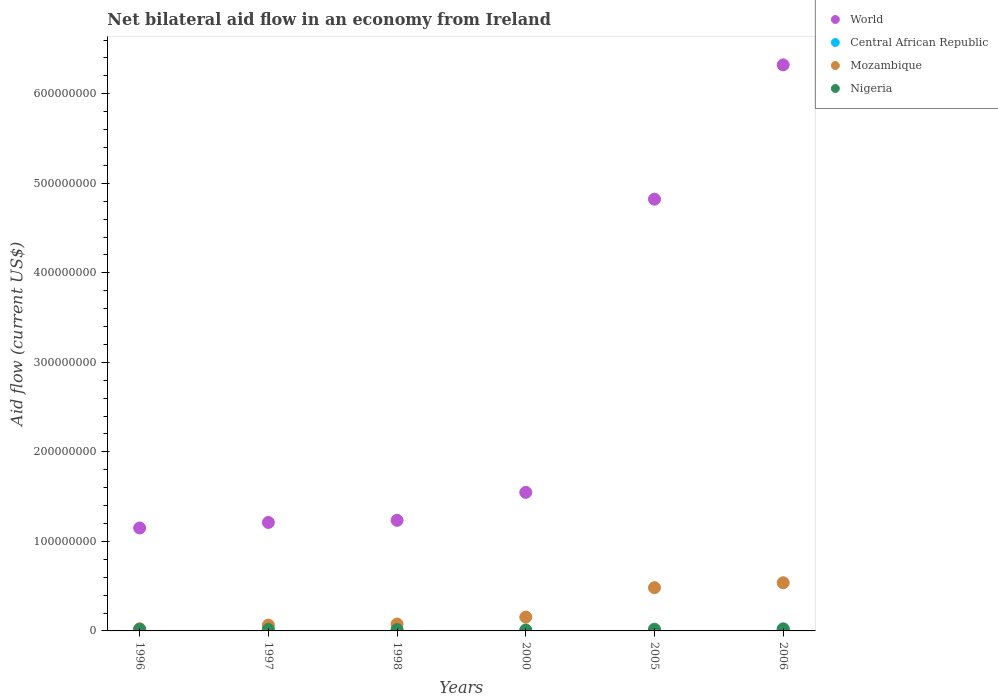How many different coloured dotlines are there?
Your answer should be compact. 4. What is the net bilateral aid flow in World in 2000?
Provide a succinct answer. 1.55e+08. Across all years, what is the maximum net bilateral aid flow in Mozambique?
Ensure brevity in your answer.  5.38e+07. Across all years, what is the minimum net bilateral aid flow in Nigeria?
Your response must be concise. 9.90e+05. In which year was the net bilateral aid flow in Central African Republic maximum?
Your answer should be very brief. 2006. What is the total net bilateral aid flow in Central African Republic in the graph?
Your answer should be compact. 2.30e+06. What is the difference between the net bilateral aid flow in Central African Republic in 1996 and that in 2000?
Ensure brevity in your answer.  0. What is the difference between the net bilateral aid flow in Nigeria in 2006 and the net bilateral aid flow in World in 1996?
Keep it short and to the point. -1.13e+08. What is the average net bilateral aid flow in Mozambique per year?
Make the answer very short. 2.23e+07. In the year 1998, what is the difference between the net bilateral aid flow in Mozambique and net bilateral aid flow in Central African Republic?
Offer a terse response. 7.64e+06. In how many years, is the net bilateral aid flow in Central African Republic greater than 440000000 US$?
Your response must be concise. 0. What is the ratio of the net bilateral aid flow in Central African Republic in 1997 to that in 1998?
Your answer should be very brief. 1.33. Is the net bilateral aid flow in Nigeria in 1996 less than that in 1997?
Keep it short and to the point. No. What is the difference between the highest and the second highest net bilateral aid flow in Mozambique?
Provide a short and direct response. 5.50e+06. What is the difference between the highest and the lowest net bilateral aid flow in World?
Give a very brief answer. 5.17e+08. Is it the case that in every year, the sum of the net bilateral aid flow in Central African Republic and net bilateral aid flow in Nigeria  is greater than the net bilateral aid flow in World?
Give a very brief answer. No. Does the net bilateral aid flow in Mozambique monotonically increase over the years?
Provide a short and direct response. Yes. Is the net bilateral aid flow in World strictly less than the net bilateral aid flow in Nigeria over the years?
Offer a terse response. No. How many dotlines are there?
Your answer should be compact. 4. How many years are there in the graph?
Ensure brevity in your answer.  6. Where does the legend appear in the graph?
Provide a succinct answer. Top right. How many legend labels are there?
Your answer should be compact. 4. How are the legend labels stacked?
Give a very brief answer. Vertical. What is the title of the graph?
Your response must be concise. Net bilateral aid flow in an economy from Ireland. Does "Pacific island small states" appear as one of the legend labels in the graph?
Keep it short and to the point. No. What is the label or title of the X-axis?
Provide a short and direct response. Years. What is the Aid flow (current US$) of World in 1996?
Your response must be concise. 1.15e+08. What is the Aid flow (current US$) of Mozambique in 1996?
Your answer should be compact. 2.37e+06. What is the Aid flow (current US$) in Nigeria in 1996?
Provide a succinct answer. 1.72e+06. What is the Aid flow (current US$) in World in 1997?
Your answer should be compact. 1.21e+08. What is the Aid flow (current US$) of Mozambique in 1997?
Provide a short and direct response. 6.48e+06. What is the Aid flow (current US$) in Nigeria in 1997?
Your answer should be very brief. 1.63e+06. What is the Aid flow (current US$) of World in 1998?
Give a very brief answer. 1.24e+08. What is the Aid flow (current US$) of Central African Republic in 1998?
Give a very brief answer. 3.00e+04. What is the Aid flow (current US$) of Mozambique in 1998?
Your answer should be very brief. 7.67e+06. What is the Aid flow (current US$) in Nigeria in 1998?
Provide a short and direct response. 1.46e+06. What is the Aid flow (current US$) of World in 2000?
Your response must be concise. 1.55e+08. What is the Aid flow (current US$) in Central African Republic in 2000?
Your response must be concise. 2.00e+04. What is the Aid flow (current US$) in Mozambique in 2000?
Give a very brief answer. 1.54e+07. What is the Aid flow (current US$) in Nigeria in 2000?
Your answer should be compact. 9.90e+05. What is the Aid flow (current US$) in World in 2005?
Your response must be concise. 4.82e+08. What is the Aid flow (current US$) in Mozambique in 2005?
Offer a terse response. 4.83e+07. What is the Aid flow (current US$) of Nigeria in 2005?
Your response must be concise. 1.89e+06. What is the Aid flow (current US$) in World in 2006?
Provide a short and direct response. 6.32e+08. What is the Aid flow (current US$) of Central African Republic in 2006?
Offer a very short reply. 1.69e+06. What is the Aid flow (current US$) in Mozambique in 2006?
Provide a succinct answer. 5.38e+07. What is the Aid flow (current US$) in Nigeria in 2006?
Make the answer very short. 2.32e+06. Across all years, what is the maximum Aid flow (current US$) in World?
Provide a succinct answer. 6.32e+08. Across all years, what is the maximum Aid flow (current US$) in Central African Republic?
Ensure brevity in your answer.  1.69e+06. Across all years, what is the maximum Aid flow (current US$) in Mozambique?
Your response must be concise. 5.38e+07. Across all years, what is the maximum Aid flow (current US$) of Nigeria?
Give a very brief answer. 2.32e+06. Across all years, what is the minimum Aid flow (current US$) in World?
Ensure brevity in your answer.  1.15e+08. Across all years, what is the minimum Aid flow (current US$) of Central African Republic?
Your answer should be compact. 2.00e+04. Across all years, what is the minimum Aid flow (current US$) of Mozambique?
Your response must be concise. 2.37e+06. Across all years, what is the minimum Aid flow (current US$) of Nigeria?
Your answer should be very brief. 9.90e+05. What is the total Aid flow (current US$) in World in the graph?
Keep it short and to the point. 1.63e+09. What is the total Aid flow (current US$) in Central African Republic in the graph?
Provide a succinct answer. 2.30e+06. What is the total Aid flow (current US$) in Mozambique in the graph?
Make the answer very short. 1.34e+08. What is the total Aid flow (current US$) in Nigeria in the graph?
Provide a short and direct response. 1.00e+07. What is the difference between the Aid flow (current US$) in World in 1996 and that in 1997?
Offer a terse response. -6.17e+06. What is the difference between the Aid flow (current US$) in Central African Republic in 1996 and that in 1997?
Keep it short and to the point. -2.00e+04. What is the difference between the Aid flow (current US$) of Mozambique in 1996 and that in 1997?
Make the answer very short. -4.11e+06. What is the difference between the Aid flow (current US$) in Nigeria in 1996 and that in 1997?
Keep it short and to the point. 9.00e+04. What is the difference between the Aid flow (current US$) of World in 1996 and that in 1998?
Give a very brief answer. -8.53e+06. What is the difference between the Aid flow (current US$) of Mozambique in 1996 and that in 1998?
Offer a very short reply. -5.30e+06. What is the difference between the Aid flow (current US$) of Nigeria in 1996 and that in 1998?
Make the answer very short. 2.60e+05. What is the difference between the Aid flow (current US$) in World in 1996 and that in 2000?
Provide a succinct answer. -3.98e+07. What is the difference between the Aid flow (current US$) in Central African Republic in 1996 and that in 2000?
Ensure brevity in your answer.  0. What is the difference between the Aid flow (current US$) of Mozambique in 1996 and that in 2000?
Offer a terse response. -1.30e+07. What is the difference between the Aid flow (current US$) of Nigeria in 1996 and that in 2000?
Provide a short and direct response. 7.30e+05. What is the difference between the Aid flow (current US$) in World in 1996 and that in 2005?
Make the answer very short. -3.67e+08. What is the difference between the Aid flow (current US$) of Central African Republic in 1996 and that in 2005?
Offer a terse response. -4.80e+05. What is the difference between the Aid flow (current US$) in Mozambique in 1996 and that in 2005?
Your answer should be compact. -4.59e+07. What is the difference between the Aid flow (current US$) in Nigeria in 1996 and that in 2005?
Your response must be concise. -1.70e+05. What is the difference between the Aid flow (current US$) of World in 1996 and that in 2006?
Make the answer very short. -5.17e+08. What is the difference between the Aid flow (current US$) in Central African Republic in 1996 and that in 2006?
Your answer should be compact. -1.67e+06. What is the difference between the Aid flow (current US$) in Mozambique in 1996 and that in 2006?
Give a very brief answer. -5.14e+07. What is the difference between the Aid flow (current US$) of Nigeria in 1996 and that in 2006?
Provide a short and direct response. -6.00e+05. What is the difference between the Aid flow (current US$) in World in 1997 and that in 1998?
Your answer should be very brief. -2.36e+06. What is the difference between the Aid flow (current US$) in Mozambique in 1997 and that in 1998?
Your answer should be compact. -1.19e+06. What is the difference between the Aid flow (current US$) in Nigeria in 1997 and that in 1998?
Make the answer very short. 1.70e+05. What is the difference between the Aid flow (current US$) of World in 1997 and that in 2000?
Keep it short and to the point. -3.36e+07. What is the difference between the Aid flow (current US$) of Central African Republic in 1997 and that in 2000?
Offer a terse response. 2.00e+04. What is the difference between the Aid flow (current US$) in Mozambique in 1997 and that in 2000?
Your answer should be very brief. -8.91e+06. What is the difference between the Aid flow (current US$) in Nigeria in 1997 and that in 2000?
Your answer should be very brief. 6.40e+05. What is the difference between the Aid flow (current US$) in World in 1997 and that in 2005?
Keep it short and to the point. -3.61e+08. What is the difference between the Aid flow (current US$) in Central African Republic in 1997 and that in 2005?
Provide a succinct answer. -4.60e+05. What is the difference between the Aid flow (current US$) in Mozambique in 1997 and that in 2005?
Your answer should be compact. -4.18e+07. What is the difference between the Aid flow (current US$) in World in 1997 and that in 2006?
Your answer should be very brief. -5.11e+08. What is the difference between the Aid flow (current US$) of Central African Republic in 1997 and that in 2006?
Your response must be concise. -1.65e+06. What is the difference between the Aid flow (current US$) in Mozambique in 1997 and that in 2006?
Keep it short and to the point. -4.73e+07. What is the difference between the Aid flow (current US$) in Nigeria in 1997 and that in 2006?
Your answer should be very brief. -6.90e+05. What is the difference between the Aid flow (current US$) in World in 1998 and that in 2000?
Your answer should be very brief. -3.12e+07. What is the difference between the Aid flow (current US$) in Mozambique in 1998 and that in 2000?
Give a very brief answer. -7.72e+06. What is the difference between the Aid flow (current US$) of Nigeria in 1998 and that in 2000?
Give a very brief answer. 4.70e+05. What is the difference between the Aid flow (current US$) of World in 1998 and that in 2005?
Your answer should be very brief. -3.59e+08. What is the difference between the Aid flow (current US$) of Central African Republic in 1998 and that in 2005?
Your answer should be very brief. -4.70e+05. What is the difference between the Aid flow (current US$) in Mozambique in 1998 and that in 2005?
Offer a terse response. -4.06e+07. What is the difference between the Aid flow (current US$) of Nigeria in 1998 and that in 2005?
Offer a very short reply. -4.30e+05. What is the difference between the Aid flow (current US$) of World in 1998 and that in 2006?
Offer a terse response. -5.09e+08. What is the difference between the Aid flow (current US$) in Central African Republic in 1998 and that in 2006?
Provide a succinct answer. -1.66e+06. What is the difference between the Aid flow (current US$) in Mozambique in 1998 and that in 2006?
Make the answer very short. -4.61e+07. What is the difference between the Aid flow (current US$) in Nigeria in 1998 and that in 2006?
Provide a short and direct response. -8.60e+05. What is the difference between the Aid flow (current US$) in World in 2000 and that in 2005?
Keep it short and to the point. -3.28e+08. What is the difference between the Aid flow (current US$) in Central African Republic in 2000 and that in 2005?
Give a very brief answer. -4.80e+05. What is the difference between the Aid flow (current US$) in Mozambique in 2000 and that in 2005?
Make the answer very short. -3.29e+07. What is the difference between the Aid flow (current US$) of Nigeria in 2000 and that in 2005?
Make the answer very short. -9.00e+05. What is the difference between the Aid flow (current US$) of World in 2000 and that in 2006?
Keep it short and to the point. -4.78e+08. What is the difference between the Aid flow (current US$) of Central African Republic in 2000 and that in 2006?
Your answer should be compact. -1.67e+06. What is the difference between the Aid flow (current US$) in Mozambique in 2000 and that in 2006?
Offer a terse response. -3.84e+07. What is the difference between the Aid flow (current US$) of Nigeria in 2000 and that in 2006?
Provide a short and direct response. -1.33e+06. What is the difference between the Aid flow (current US$) in World in 2005 and that in 2006?
Provide a short and direct response. -1.50e+08. What is the difference between the Aid flow (current US$) of Central African Republic in 2005 and that in 2006?
Your response must be concise. -1.19e+06. What is the difference between the Aid flow (current US$) of Mozambique in 2005 and that in 2006?
Give a very brief answer. -5.50e+06. What is the difference between the Aid flow (current US$) of Nigeria in 2005 and that in 2006?
Offer a very short reply. -4.30e+05. What is the difference between the Aid flow (current US$) of World in 1996 and the Aid flow (current US$) of Central African Republic in 1997?
Make the answer very short. 1.15e+08. What is the difference between the Aid flow (current US$) of World in 1996 and the Aid flow (current US$) of Mozambique in 1997?
Make the answer very short. 1.09e+08. What is the difference between the Aid flow (current US$) in World in 1996 and the Aid flow (current US$) in Nigeria in 1997?
Give a very brief answer. 1.13e+08. What is the difference between the Aid flow (current US$) in Central African Republic in 1996 and the Aid flow (current US$) in Mozambique in 1997?
Offer a very short reply. -6.46e+06. What is the difference between the Aid flow (current US$) of Central African Republic in 1996 and the Aid flow (current US$) of Nigeria in 1997?
Provide a short and direct response. -1.61e+06. What is the difference between the Aid flow (current US$) of Mozambique in 1996 and the Aid flow (current US$) of Nigeria in 1997?
Keep it short and to the point. 7.40e+05. What is the difference between the Aid flow (current US$) in World in 1996 and the Aid flow (current US$) in Central African Republic in 1998?
Keep it short and to the point. 1.15e+08. What is the difference between the Aid flow (current US$) in World in 1996 and the Aid flow (current US$) in Mozambique in 1998?
Keep it short and to the point. 1.07e+08. What is the difference between the Aid flow (current US$) in World in 1996 and the Aid flow (current US$) in Nigeria in 1998?
Keep it short and to the point. 1.14e+08. What is the difference between the Aid flow (current US$) in Central African Republic in 1996 and the Aid flow (current US$) in Mozambique in 1998?
Give a very brief answer. -7.65e+06. What is the difference between the Aid flow (current US$) of Central African Republic in 1996 and the Aid flow (current US$) of Nigeria in 1998?
Offer a very short reply. -1.44e+06. What is the difference between the Aid flow (current US$) of Mozambique in 1996 and the Aid flow (current US$) of Nigeria in 1998?
Your response must be concise. 9.10e+05. What is the difference between the Aid flow (current US$) of World in 1996 and the Aid flow (current US$) of Central African Republic in 2000?
Your answer should be compact. 1.15e+08. What is the difference between the Aid flow (current US$) of World in 1996 and the Aid flow (current US$) of Mozambique in 2000?
Offer a terse response. 9.96e+07. What is the difference between the Aid flow (current US$) in World in 1996 and the Aid flow (current US$) in Nigeria in 2000?
Provide a short and direct response. 1.14e+08. What is the difference between the Aid flow (current US$) in Central African Republic in 1996 and the Aid flow (current US$) in Mozambique in 2000?
Your answer should be compact. -1.54e+07. What is the difference between the Aid flow (current US$) in Central African Republic in 1996 and the Aid flow (current US$) in Nigeria in 2000?
Provide a succinct answer. -9.70e+05. What is the difference between the Aid flow (current US$) in Mozambique in 1996 and the Aid flow (current US$) in Nigeria in 2000?
Your answer should be very brief. 1.38e+06. What is the difference between the Aid flow (current US$) of World in 1996 and the Aid flow (current US$) of Central African Republic in 2005?
Your response must be concise. 1.14e+08. What is the difference between the Aid flow (current US$) in World in 1996 and the Aid flow (current US$) in Mozambique in 2005?
Give a very brief answer. 6.67e+07. What is the difference between the Aid flow (current US$) in World in 1996 and the Aid flow (current US$) in Nigeria in 2005?
Offer a very short reply. 1.13e+08. What is the difference between the Aid flow (current US$) of Central African Republic in 1996 and the Aid flow (current US$) of Mozambique in 2005?
Your answer should be compact. -4.83e+07. What is the difference between the Aid flow (current US$) of Central African Republic in 1996 and the Aid flow (current US$) of Nigeria in 2005?
Ensure brevity in your answer.  -1.87e+06. What is the difference between the Aid flow (current US$) of World in 1996 and the Aid flow (current US$) of Central African Republic in 2006?
Ensure brevity in your answer.  1.13e+08. What is the difference between the Aid flow (current US$) of World in 1996 and the Aid flow (current US$) of Mozambique in 2006?
Provide a succinct answer. 6.12e+07. What is the difference between the Aid flow (current US$) in World in 1996 and the Aid flow (current US$) in Nigeria in 2006?
Your answer should be very brief. 1.13e+08. What is the difference between the Aid flow (current US$) in Central African Republic in 1996 and the Aid flow (current US$) in Mozambique in 2006?
Give a very brief answer. -5.38e+07. What is the difference between the Aid flow (current US$) of Central African Republic in 1996 and the Aid flow (current US$) of Nigeria in 2006?
Your answer should be very brief. -2.30e+06. What is the difference between the Aid flow (current US$) in Mozambique in 1996 and the Aid flow (current US$) in Nigeria in 2006?
Offer a terse response. 5.00e+04. What is the difference between the Aid flow (current US$) of World in 1997 and the Aid flow (current US$) of Central African Republic in 1998?
Keep it short and to the point. 1.21e+08. What is the difference between the Aid flow (current US$) in World in 1997 and the Aid flow (current US$) in Mozambique in 1998?
Provide a succinct answer. 1.13e+08. What is the difference between the Aid flow (current US$) of World in 1997 and the Aid flow (current US$) of Nigeria in 1998?
Provide a short and direct response. 1.20e+08. What is the difference between the Aid flow (current US$) in Central African Republic in 1997 and the Aid flow (current US$) in Mozambique in 1998?
Make the answer very short. -7.63e+06. What is the difference between the Aid flow (current US$) in Central African Republic in 1997 and the Aid flow (current US$) in Nigeria in 1998?
Provide a short and direct response. -1.42e+06. What is the difference between the Aid flow (current US$) in Mozambique in 1997 and the Aid flow (current US$) in Nigeria in 1998?
Offer a very short reply. 5.02e+06. What is the difference between the Aid flow (current US$) of World in 1997 and the Aid flow (current US$) of Central African Republic in 2000?
Provide a short and direct response. 1.21e+08. What is the difference between the Aid flow (current US$) in World in 1997 and the Aid flow (current US$) in Mozambique in 2000?
Provide a short and direct response. 1.06e+08. What is the difference between the Aid flow (current US$) in World in 1997 and the Aid flow (current US$) in Nigeria in 2000?
Give a very brief answer. 1.20e+08. What is the difference between the Aid flow (current US$) in Central African Republic in 1997 and the Aid flow (current US$) in Mozambique in 2000?
Provide a short and direct response. -1.54e+07. What is the difference between the Aid flow (current US$) in Central African Republic in 1997 and the Aid flow (current US$) in Nigeria in 2000?
Provide a succinct answer. -9.50e+05. What is the difference between the Aid flow (current US$) in Mozambique in 1997 and the Aid flow (current US$) in Nigeria in 2000?
Ensure brevity in your answer.  5.49e+06. What is the difference between the Aid flow (current US$) in World in 1997 and the Aid flow (current US$) in Central African Republic in 2005?
Ensure brevity in your answer.  1.21e+08. What is the difference between the Aid flow (current US$) in World in 1997 and the Aid flow (current US$) in Mozambique in 2005?
Your answer should be very brief. 7.28e+07. What is the difference between the Aid flow (current US$) of World in 1997 and the Aid flow (current US$) of Nigeria in 2005?
Your answer should be very brief. 1.19e+08. What is the difference between the Aid flow (current US$) in Central African Republic in 1997 and the Aid flow (current US$) in Mozambique in 2005?
Your response must be concise. -4.83e+07. What is the difference between the Aid flow (current US$) in Central African Republic in 1997 and the Aid flow (current US$) in Nigeria in 2005?
Provide a succinct answer. -1.85e+06. What is the difference between the Aid flow (current US$) in Mozambique in 1997 and the Aid flow (current US$) in Nigeria in 2005?
Your answer should be compact. 4.59e+06. What is the difference between the Aid flow (current US$) of World in 1997 and the Aid flow (current US$) of Central African Republic in 2006?
Keep it short and to the point. 1.19e+08. What is the difference between the Aid flow (current US$) in World in 1997 and the Aid flow (current US$) in Mozambique in 2006?
Give a very brief answer. 6.74e+07. What is the difference between the Aid flow (current US$) of World in 1997 and the Aid flow (current US$) of Nigeria in 2006?
Your answer should be very brief. 1.19e+08. What is the difference between the Aid flow (current US$) in Central African Republic in 1997 and the Aid flow (current US$) in Mozambique in 2006?
Your response must be concise. -5.38e+07. What is the difference between the Aid flow (current US$) in Central African Republic in 1997 and the Aid flow (current US$) in Nigeria in 2006?
Offer a terse response. -2.28e+06. What is the difference between the Aid flow (current US$) in Mozambique in 1997 and the Aid flow (current US$) in Nigeria in 2006?
Provide a short and direct response. 4.16e+06. What is the difference between the Aid flow (current US$) in World in 1998 and the Aid flow (current US$) in Central African Republic in 2000?
Your answer should be very brief. 1.24e+08. What is the difference between the Aid flow (current US$) in World in 1998 and the Aid flow (current US$) in Mozambique in 2000?
Keep it short and to the point. 1.08e+08. What is the difference between the Aid flow (current US$) in World in 1998 and the Aid flow (current US$) in Nigeria in 2000?
Give a very brief answer. 1.23e+08. What is the difference between the Aid flow (current US$) in Central African Republic in 1998 and the Aid flow (current US$) in Mozambique in 2000?
Keep it short and to the point. -1.54e+07. What is the difference between the Aid flow (current US$) in Central African Republic in 1998 and the Aid flow (current US$) in Nigeria in 2000?
Your answer should be very brief. -9.60e+05. What is the difference between the Aid flow (current US$) in Mozambique in 1998 and the Aid flow (current US$) in Nigeria in 2000?
Make the answer very short. 6.68e+06. What is the difference between the Aid flow (current US$) of World in 1998 and the Aid flow (current US$) of Central African Republic in 2005?
Your answer should be compact. 1.23e+08. What is the difference between the Aid flow (current US$) in World in 1998 and the Aid flow (current US$) in Mozambique in 2005?
Keep it short and to the point. 7.52e+07. What is the difference between the Aid flow (current US$) in World in 1998 and the Aid flow (current US$) in Nigeria in 2005?
Your answer should be compact. 1.22e+08. What is the difference between the Aid flow (current US$) in Central African Republic in 1998 and the Aid flow (current US$) in Mozambique in 2005?
Provide a succinct answer. -4.83e+07. What is the difference between the Aid flow (current US$) in Central African Republic in 1998 and the Aid flow (current US$) in Nigeria in 2005?
Your answer should be very brief. -1.86e+06. What is the difference between the Aid flow (current US$) of Mozambique in 1998 and the Aid flow (current US$) of Nigeria in 2005?
Your answer should be compact. 5.78e+06. What is the difference between the Aid flow (current US$) in World in 1998 and the Aid flow (current US$) in Central African Republic in 2006?
Offer a terse response. 1.22e+08. What is the difference between the Aid flow (current US$) in World in 1998 and the Aid flow (current US$) in Mozambique in 2006?
Offer a terse response. 6.97e+07. What is the difference between the Aid flow (current US$) of World in 1998 and the Aid flow (current US$) of Nigeria in 2006?
Your answer should be compact. 1.21e+08. What is the difference between the Aid flow (current US$) in Central African Republic in 1998 and the Aid flow (current US$) in Mozambique in 2006?
Your answer should be very brief. -5.38e+07. What is the difference between the Aid flow (current US$) of Central African Republic in 1998 and the Aid flow (current US$) of Nigeria in 2006?
Offer a very short reply. -2.29e+06. What is the difference between the Aid flow (current US$) of Mozambique in 1998 and the Aid flow (current US$) of Nigeria in 2006?
Offer a very short reply. 5.35e+06. What is the difference between the Aid flow (current US$) in World in 2000 and the Aid flow (current US$) in Central African Republic in 2005?
Provide a succinct answer. 1.54e+08. What is the difference between the Aid flow (current US$) in World in 2000 and the Aid flow (current US$) in Mozambique in 2005?
Offer a very short reply. 1.06e+08. What is the difference between the Aid flow (current US$) of World in 2000 and the Aid flow (current US$) of Nigeria in 2005?
Your answer should be very brief. 1.53e+08. What is the difference between the Aid flow (current US$) of Central African Republic in 2000 and the Aid flow (current US$) of Mozambique in 2005?
Give a very brief answer. -4.83e+07. What is the difference between the Aid flow (current US$) of Central African Republic in 2000 and the Aid flow (current US$) of Nigeria in 2005?
Your answer should be compact. -1.87e+06. What is the difference between the Aid flow (current US$) of Mozambique in 2000 and the Aid flow (current US$) of Nigeria in 2005?
Your answer should be compact. 1.35e+07. What is the difference between the Aid flow (current US$) of World in 2000 and the Aid flow (current US$) of Central African Republic in 2006?
Make the answer very short. 1.53e+08. What is the difference between the Aid flow (current US$) of World in 2000 and the Aid flow (current US$) of Mozambique in 2006?
Ensure brevity in your answer.  1.01e+08. What is the difference between the Aid flow (current US$) of World in 2000 and the Aid flow (current US$) of Nigeria in 2006?
Your answer should be very brief. 1.52e+08. What is the difference between the Aid flow (current US$) of Central African Republic in 2000 and the Aid flow (current US$) of Mozambique in 2006?
Make the answer very short. -5.38e+07. What is the difference between the Aid flow (current US$) of Central African Republic in 2000 and the Aid flow (current US$) of Nigeria in 2006?
Offer a very short reply. -2.30e+06. What is the difference between the Aid flow (current US$) in Mozambique in 2000 and the Aid flow (current US$) in Nigeria in 2006?
Your answer should be very brief. 1.31e+07. What is the difference between the Aid flow (current US$) in World in 2005 and the Aid flow (current US$) in Central African Republic in 2006?
Ensure brevity in your answer.  4.81e+08. What is the difference between the Aid flow (current US$) in World in 2005 and the Aid flow (current US$) in Mozambique in 2006?
Your answer should be very brief. 4.28e+08. What is the difference between the Aid flow (current US$) of World in 2005 and the Aid flow (current US$) of Nigeria in 2006?
Your answer should be compact. 4.80e+08. What is the difference between the Aid flow (current US$) of Central African Republic in 2005 and the Aid flow (current US$) of Mozambique in 2006?
Offer a terse response. -5.33e+07. What is the difference between the Aid flow (current US$) in Central African Republic in 2005 and the Aid flow (current US$) in Nigeria in 2006?
Offer a terse response. -1.82e+06. What is the difference between the Aid flow (current US$) in Mozambique in 2005 and the Aid flow (current US$) in Nigeria in 2006?
Your answer should be very brief. 4.60e+07. What is the average Aid flow (current US$) of World per year?
Offer a terse response. 2.71e+08. What is the average Aid flow (current US$) of Central African Republic per year?
Offer a very short reply. 3.83e+05. What is the average Aid flow (current US$) of Mozambique per year?
Give a very brief answer. 2.23e+07. What is the average Aid flow (current US$) of Nigeria per year?
Offer a very short reply. 1.67e+06. In the year 1996, what is the difference between the Aid flow (current US$) of World and Aid flow (current US$) of Central African Republic?
Offer a terse response. 1.15e+08. In the year 1996, what is the difference between the Aid flow (current US$) in World and Aid flow (current US$) in Mozambique?
Offer a terse response. 1.13e+08. In the year 1996, what is the difference between the Aid flow (current US$) of World and Aid flow (current US$) of Nigeria?
Keep it short and to the point. 1.13e+08. In the year 1996, what is the difference between the Aid flow (current US$) of Central African Republic and Aid flow (current US$) of Mozambique?
Your response must be concise. -2.35e+06. In the year 1996, what is the difference between the Aid flow (current US$) in Central African Republic and Aid flow (current US$) in Nigeria?
Offer a very short reply. -1.70e+06. In the year 1996, what is the difference between the Aid flow (current US$) in Mozambique and Aid flow (current US$) in Nigeria?
Provide a short and direct response. 6.50e+05. In the year 1997, what is the difference between the Aid flow (current US$) of World and Aid flow (current US$) of Central African Republic?
Offer a very short reply. 1.21e+08. In the year 1997, what is the difference between the Aid flow (current US$) of World and Aid flow (current US$) of Mozambique?
Provide a succinct answer. 1.15e+08. In the year 1997, what is the difference between the Aid flow (current US$) in World and Aid flow (current US$) in Nigeria?
Your answer should be very brief. 1.20e+08. In the year 1997, what is the difference between the Aid flow (current US$) of Central African Republic and Aid flow (current US$) of Mozambique?
Ensure brevity in your answer.  -6.44e+06. In the year 1997, what is the difference between the Aid flow (current US$) in Central African Republic and Aid flow (current US$) in Nigeria?
Offer a very short reply. -1.59e+06. In the year 1997, what is the difference between the Aid flow (current US$) in Mozambique and Aid flow (current US$) in Nigeria?
Your answer should be compact. 4.85e+06. In the year 1998, what is the difference between the Aid flow (current US$) in World and Aid flow (current US$) in Central African Republic?
Make the answer very short. 1.23e+08. In the year 1998, what is the difference between the Aid flow (current US$) of World and Aid flow (current US$) of Mozambique?
Give a very brief answer. 1.16e+08. In the year 1998, what is the difference between the Aid flow (current US$) of World and Aid flow (current US$) of Nigeria?
Your answer should be very brief. 1.22e+08. In the year 1998, what is the difference between the Aid flow (current US$) in Central African Republic and Aid flow (current US$) in Mozambique?
Your answer should be compact. -7.64e+06. In the year 1998, what is the difference between the Aid flow (current US$) in Central African Republic and Aid flow (current US$) in Nigeria?
Give a very brief answer. -1.43e+06. In the year 1998, what is the difference between the Aid flow (current US$) of Mozambique and Aid flow (current US$) of Nigeria?
Your response must be concise. 6.21e+06. In the year 2000, what is the difference between the Aid flow (current US$) of World and Aid flow (current US$) of Central African Republic?
Your answer should be very brief. 1.55e+08. In the year 2000, what is the difference between the Aid flow (current US$) in World and Aid flow (current US$) in Mozambique?
Give a very brief answer. 1.39e+08. In the year 2000, what is the difference between the Aid flow (current US$) in World and Aid flow (current US$) in Nigeria?
Keep it short and to the point. 1.54e+08. In the year 2000, what is the difference between the Aid flow (current US$) in Central African Republic and Aid flow (current US$) in Mozambique?
Provide a succinct answer. -1.54e+07. In the year 2000, what is the difference between the Aid flow (current US$) of Central African Republic and Aid flow (current US$) of Nigeria?
Provide a succinct answer. -9.70e+05. In the year 2000, what is the difference between the Aid flow (current US$) in Mozambique and Aid flow (current US$) in Nigeria?
Make the answer very short. 1.44e+07. In the year 2005, what is the difference between the Aid flow (current US$) of World and Aid flow (current US$) of Central African Republic?
Offer a very short reply. 4.82e+08. In the year 2005, what is the difference between the Aid flow (current US$) of World and Aid flow (current US$) of Mozambique?
Keep it short and to the point. 4.34e+08. In the year 2005, what is the difference between the Aid flow (current US$) of World and Aid flow (current US$) of Nigeria?
Provide a short and direct response. 4.80e+08. In the year 2005, what is the difference between the Aid flow (current US$) in Central African Republic and Aid flow (current US$) in Mozambique?
Offer a very short reply. -4.78e+07. In the year 2005, what is the difference between the Aid flow (current US$) of Central African Republic and Aid flow (current US$) of Nigeria?
Your answer should be compact. -1.39e+06. In the year 2005, what is the difference between the Aid flow (current US$) in Mozambique and Aid flow (current US$) in Nigeria?
Offer a terse response. 4.64e+07. In the year 2006, what is the difference between the Aid flow (current US$) in World and Aid flow (current US$) in Central African Republic?
Offer a very short reply. 6.31e+08. In the year 2006, what is the difference between the Aid flow (current US$) of World and Aid flow (current US$) of Mozambique?
Your answer should be very brief. 5.78e+08. In the year 2006, what is the difference between the Aid flow (current US$) of World and Aid flow (current US$) of Nigeria?
Offer a terse response. 6.30e+08. In the year 2006, what is the difference between the Aid flow (current US$) of Central African Republic and Aid flow (current US$) of Mozambique?
Provide a succinct answer. -5.21e+07. In the year 2006, what is the difference between the Aid flow (current US$) of Central African Republic and Aid flow (current US$) of Nigeria?
Provide a short and direct response. -6.30e+05. In the year 2006, what is the difference between the Aid flow (current US$) in Mozambique and Aid flow (current US$) in Nigeria?
Your answer should be very brief. 5.15e+07. What is the ratio of the Aid flow (current US$) of World in 1996 to that in 1997?
Ensure brevity in your answer.  0.95. What is the ratio of the Aid flow (current US$) of Mozambique in 1996 to that in 1997?
Provide a succinct answer. 0.37. What is the ratio of the Aid flow (current US$) of Nigeria in 1996 to that in 1997?
Give a very brief answer. 1.06. What is the ratio of the Aid flow (current US$) of World in 1996 to that in 1998?
Give a very brief answer. 0.93. What is the ratio of the Aid flow (current US$) of Central African Republic in 1996 to that in 1998?
Make the answer very short. 0.67. What is the ratio of the Aid flow (current US$) in Mozambique in 1996 to that in 1998?
Offer a terse response. 0.31. What is the ratio of the Aid flow (current US$) of Nigeria in 1996 to that in 1998?
Ensure brevity in your answer.  1.18. What is the ratio of the Aid flow (current US$) of World in 1996 to that in 2000?
Give a very brief answer. 0.74. What is the ratio of the Aid flow (current US$) in Mozambique in 1996 to that in 2000?
Offer a very short reply. 0.15. What is the ratio of the Aid flow (current US$) in Nigeria in 1996 to that in 2000?
Ensure brevity in your answer.  1.74. What is the ratio of the Aid flow (current US$) of World in 1996 to that in 2005?
Provide a short and direct response. 0.24. What is the ratio of the Aid flow (current US$) in Central African Republic in 1996 to that in 2005?
Ensure brevity in your answer.  0.04. What is the ratio of the Aid flow (current US$) in Mozambique in 1996 to that in 2005?
Give a very brief answer. 0.05. What is the ratio of the Aid flow (current US$) in Nigeria in 1996 to that in 2005?
Provide a short and direct response. 0.91. What is the ratio of the Aid flow (current US$) in World in 1996 to that in 2006?
Ensure brevity in your answer.  0.18. What is the ratio of the Aid flow (current US$) of Central African Republic in 1996 to that in 2006?
Offer a terse response. 0.01. What is the ratio of the Aid flow (current US$) in Mozambique in 1996 to that in 2006?
Give a very brief answer. 0.04. What is the ratio of the Aid flow (current US$) in Nigeria in 1996 to that in 2006?
Give a very brief answer. 0.74. What is the ratio of the Aid flow (current US$) in World in 1997 to that in 1998?
Provide a short and direct response. 0.98. What is the ratio of the Aid flow (current US$) of Central African Republic in 1997 to that in 1998?
Your answer should be compact. 1.33. What is the ratio of the Aid flow (current US$) in Mozambique in 1997 to that in 1998?
Make the answer very short. 0.84. What is the ratio of the Aid flow (current US$) in Nigeria in 1997 to that in 1998?
Your answer should be compact. 1.12. What is the ratio of the Aid flow (current US$) of World in 1997 to that in 2000?
Offer a very short reply. 0.78. What is the ratio of the Aid flow (current US$) in Central African Republic in 1997 to that in 2000?
Provide a succinct answer. 2. What is the ratio of the Aid flow (current US$) in Mozambique in 1997 to that in 2000?
Keep it short and to the point. 0.42. What is the ratio of the Aid flow (current US$) of Nigeria in 1997 to that in 2000?
Provide a succinct answer. 1.65. What is the ratio of the Aid flow (current US$) of World in 1997 to that in 2005?
Offer a terse response. 0.25. What is the ratio of the Aid flow (current US$) of Central African Republic in 1997 to that in 2005?
Your answer should be very brief. 0.08. What is the ratio of the Aid flow (current US$) of Mozambique in 1997 to that in 2005?
Your answer should be compact. 0.13. What is the ratio of the Aid flow (current US$) of Nigeria in 1997 to that in 2005?
Your response must be concise. 0.86. What is the ratio of the Aid flow (current US$) of World in 1997 to that in 2006?
Keep it short and to the point. 0.19. What is the ratio of the Aid flow (current US$) of Central African Republic in 1997 to that in 2006?
Offer a very short reply. 0.02. What is the ratio of the Aid flow (current US$) in Mozambique in 1997 to that in 2006?
Offer a terse response. 0.12. What is the ratio of the Aid flow (current US$) of Nigeria in 1997 to that in 2006?
Give a very brief answer. 0.7. What is the ratio of the Aid flow (current US$) of World in 1998 to that in 2000?
Your response must be concise. 0.8. What is the ratio of the Aid flow (current US$) of Central African Republic in 1998 to that in 2000?
Ensure brevity in your answer.  1.5. What is the ratio of the Aid flow (current US$) of Mozambique in 1998 to that in 2000?
Give a very brief answer. 0.5. What is the ratio of the Aid flow (current US$) of Nigeria in 1998 to that in 2000?
Your answer should be compact. 1.47. What is the ratio of the Aid flow (current US$) in World in 1998 to that in 2005?
Your answer should be very brief. 0.26. What is the ratio of the Aid flow (current US$) of Central African Republic in 1998 to that in 2005?
Your response must be concise. 0.06. What is the ratio of the Aid flow (current US$) in Mozambique in 1998 to that in 2005?
Give a very brief answer. 0.16. What is the ratio of the Aid flow (current US$) in Nigeria in 1998 to that in 2005?
Give a very brief answer. 0.77. What is the ratio of the Aid flow (current US$) in World in 1998 to that in 2006?
Offer a very short reply. 0.2. What is the ratio of the Aid flow (current US$) in Central African Republic in 1998 to that in 2006?
Provide a short and direct response. 0.02. What is the ratio of the Aid flow (current US$) in Mozambique in 1998 to that in 2006?
Your answer should be very brief. 0.14. What is the ratio of the Aid flow (current US$) of Nigeria in 1998 to that in 2006?
Keep it short and to the point. 0.63. What is the ratio of the Aid flow (current US$) in World in 2000 to that in 2005?
Ensure brevity in your answer.  0.32. What is the ratio of the Aid flow (current US$) of Mozambique in 2000 to that in 2005?
Your response must be concise. 0.32. What is the ratio of the Aid flow (current US$) of Nigeria in 2000 to that in 2005?
Offer a terse response. 0.52. What is the ratio of the Aid flow (current US$) of World in 2000 to that in 2006?
Offer a terse response. 0.24. What is the ratio of the Aid flow (current US$) of Central African Republic in 2000 to that in 2006?
Provide a short and direct response. 0.01. What is the ratio of the Aid flow (current US$) in Mozambique in 2000 to that in 2006?
Provide a short and direct response. 0.29. What is the ratio of the Aid flow (current US$) of Nigeria in 2000 to that in 2006?
Offer a terse response. 0.43. What is the ratio of the Aid flow (current US$) in World in 2005 to that in 2006?
Provide a short and direct response. 0.76. What is the ratio of the Aid flow (current US$) in Central African Republic in 2005 to that in 2006?
Provide a short and direct response. 0.3. What is the ratio of the Aid flow (current US$) of Mozambique in 2005 to that in 2006?
Give a very brief answer. 0.9. What is the ratio of the Aid flow (current US$) of Nigeria in 2005 to that in 2006?
Provide a succinct answer. 0.81. What is the difference between the highest and the second highest Aid flow (current US$) in World?
Offer a very short reply. 1.50e+08. What is the difference between the highest and the second highest Aid flow (current US$) in Central African Republic?
Keep it short and to the point. 1.19e+06. What is the difference between the highest and the second highest Aid flow (current US$) of Mozambique?
Provide a succinct answer. 5.50e+06. What is the difference between the highest and the lowest Aid flow (current US$) in World?
Give a very brief answer. 5.17e+08. What is the difference between the highest and the lowest Aid flow (current US$) of Central African Republic?
Provide a succinct answer. 1.67e+06. What is the difference between the highest and the lowest Aid flow (current US$) in Mozambique?
Make the answer very short. 5.14e+07. What is the difference between the highest and the lowest Aid flow (current US$) in Nigeria?
Provide a succinct answer. 1.33e+06. 